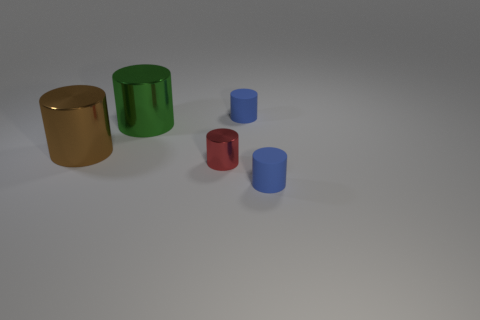Subtract all metal cylinders. How many cylinders are left? 2 Subtract all blue cylinders. How many cylinders are left? 3 Subtract 1 brown cylinders. How many objects are left? 4 Subtract 1 cylinders. How many cylinders are left? 4 Subtract all yellow cylinders. Subtract all brown cubes. How many cylinders are left? 5 Subtract all cyan spheres. How many red cylinders are left? 1 Subtract all green cylinders. Subtract all small purple things. How many objects are left? 4 Add 3 tiny cylinders. How many tiny cylinders are left? 6 Add 3 cyan matte spheres. How many cyan matte spheres exist? 3 Add 4 gray matte balls. How many objects exist? 9 